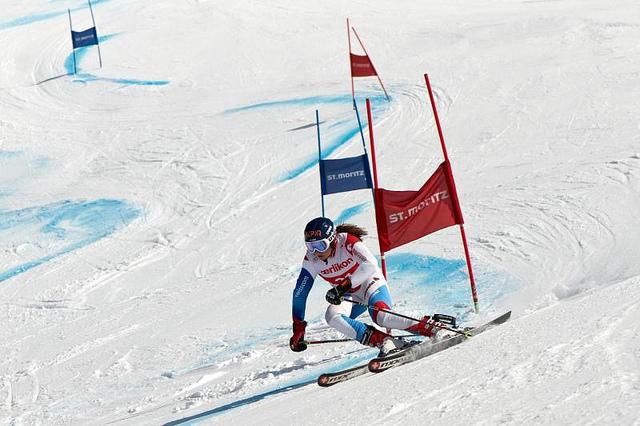Is the snow fresh?
Short answer required. No. How many poles?
Short answer required. 2. Is this slalom skiing?
Concise answer only. Yes. 